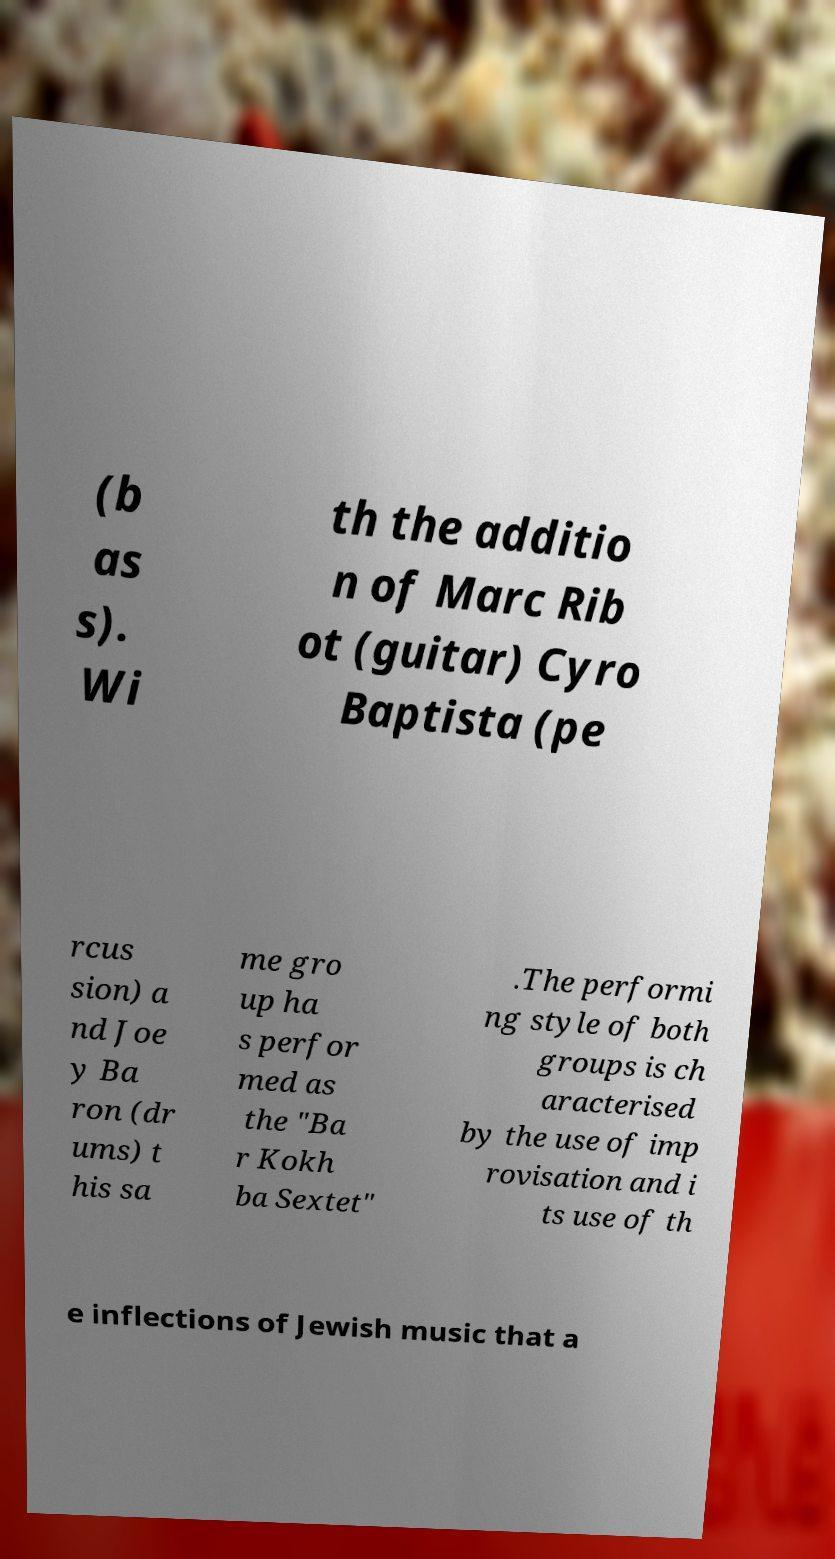Could you extract and type out the text from this image? (b as s). Wi th the additio n of Marc Rib ot (guitar) Cyro Baptista (pe rcus sion) a nd Joe y Ba ron (dr ums) t his sa me gro up ha s perfor med as the "Ba r Kokh ba Sextet" .The performi ng style of both groups is ch aracterised by the use of imp rovisation and i ts use of th e inflections of Jewish music that a 